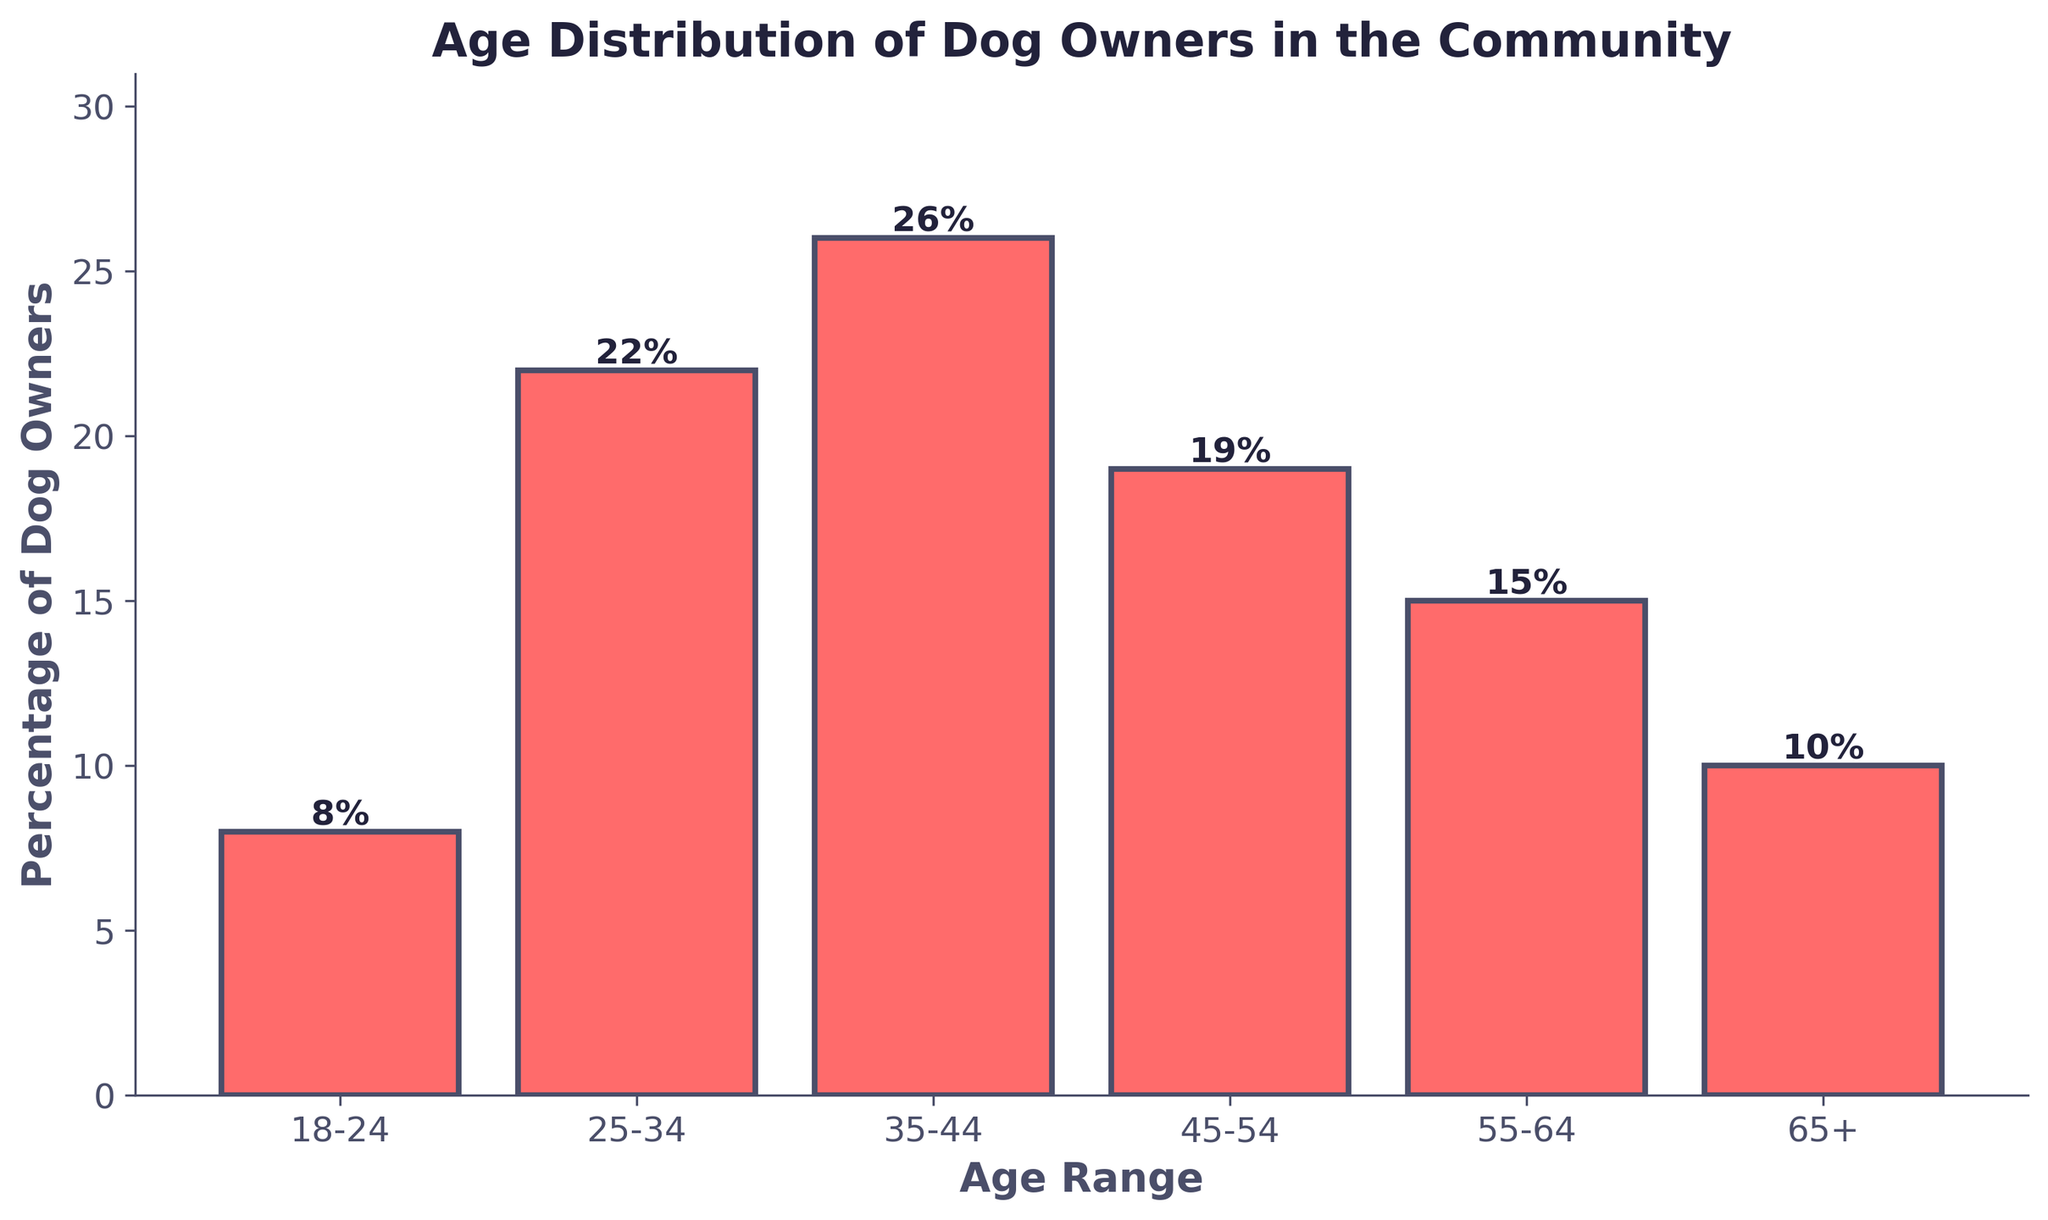What is the age range with the highest percentage of dog owners? The figure shows six age ranges, and the tallest bar corresponds to the age range 35-44 with a percentage of 26%. Thus, 35-44 is the age range with the highest percentage of dog owners.
Answer: 35-44 Which two age ranges have a combined percentage of dog owners that equals 33%? By adding up the percentages, the age ranges 55-64 (15%) and 65+ (10%) add up to 25%, but 18-24 (8%) and 25-34 (22%) add up to 30%. However, the 25-34 (22%) and 45-54 (19%) sum up to 41%, the correct combination is 8 (18-24) + 25 (45-54) = 33%.
Answer: 18-24 and 45-54 How much greater is the percentage of dog owners aged 35-44 compared to 18-24? The percentage of dog owners aged 35-44 is 26%, and for 18-24, it is 8%. The difference is calculated by subtracting 8% from 26%, which results in 18%.
Answer: 18% What is the total percentage of dog owners aged 25-34 and 55-64? The figure indicates the percentages for these two age ranges: 25-34 is 22%, and 55-64 is 15%. Adding these values gives 22% + 15% = 37%.
Answer: 37% What is the smallest age range percentage and what is it? The figure indicates that the smallest percentage bar is for the age range 18-24, with a percentage of 8%.
Answer: 18-24, 8% Which is larger, the combined percentage of dog owners for the age ranges 18-24 and 65+, or the percentage for the age range 45-54? The combined percentage for 18-24 (8%) and 65+ (10%) is 18%, while the percentage for the 45-54 age range is 19%. Thus, 45-54 is larger.
Answer: 45-54 What is the average percentage of dog owners for all age ranges? To find the average, add all the percentages: 8 + 22 + 26 + 19 + 15 + 10 = 100%. Then, divide by the number of age ranges, which is 6. So, 100% / 6 = 16.67%.
Answer: 16.67% What percentage of dog owners are 45 years or older? Sum the percentages for age ranges 45-54, 55-64, and 65+: 19% + 15% + 10% = 44%.
Answer: 44% What is the median age range percentage of dog owners? The percentages in ascending order are 8, 10, 15, 19, 22, and 26. The median is the middle value in this ordered list, for an even number of items, it is the average of the two middle numbers: (15 + 19) / 2 = 17%.
Answer: 17% Which age range's dog owner percentage is closer to the average percentage? The average percentage is 16.67%. Comparing this to each age range's percentage shows that 15% is closest to 16.67%.
Answer: 55-64 